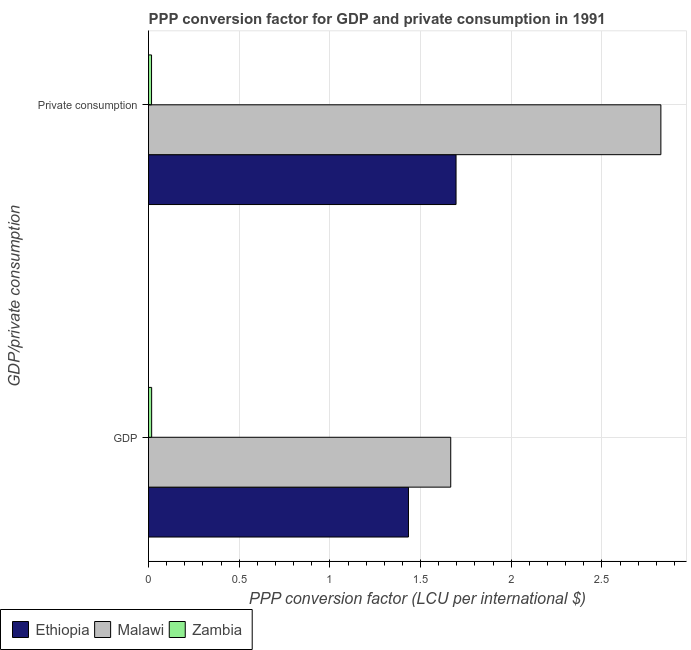How many different coloured bars are there?
Make the answer very short. 3. How many groups of bars are there?
Provide a succinct answer. 2. Are the number of bars per tick equal to the number of legend labels?
Offer a very short reply. Yes. Are the number of bars on each tick of the Y-axis equal?
Your answer should be compact. Yes. What is the label of the 1st group of bars from the top?
Your response must be concise.  Private consumption. What is the ppp conversion factor for private consumption in Malawi?
Your answer should be compact. 2.83. Across all countries, what is the maximum ppp conversion factor for private consumption?
Ensure brevity in your answer.  2.83. Across all countries, what is the minimum ppp conversion factor for private consumption?
Your answer should be compact. 0.02. In which country was the ppp conversion factor for private consumption maximum?
Your response must be concise. Malawi. In which country was the ppp conversion factor for gdp minimum?
Provide a succinct answer. Zambia. What is the total ppp conversion factor for gdp in the graph?
Make the answer very short. 3.12. What is the difference between the ppp conversion factor for gdp in Malawi and that in Zambia?
Your response must be concise. 1.65. What is the difference between the ppp conversion factor for gdp in Malawi and the ppp conversion factor for private consumption in Ethiopia?
Give a very brief answer. -0.03. What is the average ppp conversion factor for gdp per country?
Your response must be concise. 1.04. What is the difference between the ppp conversion factor for gdp and ppp conversion factor for private consumption in Zambia?
Keep it short and to the point. 0. In how many countries, is the ppp conversion factor for gdp greater than 2.2 LCU?
Provide a short and direct response. 0. What is the ratio of the ppp conversion factor for gdp in Malawi to that in Ethiopia?
Make the answer very short. 1.16. What does the 3rd bar from the top in GDP represents?
Ensure brevity in your answer.  Ethiopia. What does the 1st bar from the bottom in  Private consumption represents?
Offer a very short reply. Ethiopia. How many bars are there?
Your response must be concise. 6. Are all the bars in the graph horizontal?
Your answer should be compact. Yes. What is the difference between two consecutive major ticks on the X-axis?
Offer a very short reply. 0.5. Where does the legend appear in the graph?
Give a very brief answer. Bottom left. What is the title of the graph?
Your answer should be very brief. PPP conversion factor for GDP and private consumption in 1991. Does "Euro area" appear as one of the legend labels in the graph?
Offer a terse response. No. What is the label or title of the X-axis?
Make the answer very short. PPP conversion factor (LCU per international $). What is the label or title of the Y-axis?
Provide a short and direct response. GDP/private consumption. What is the PPP conversion factor (LCU per international $) in Ethiopia in GDP?
Provide a succinct answer. 1.43. What is the PPP conversion factor (LCU per international $) of Malawi in GDP?
Ensure brevity in your answer.  1.67. What is the PPP conversion factor (LCU per international $) of Zambia in GDP?
Your response must be concise. 0.02. What is the PPP conversion factor (LCU per international $) of Ethiopia in  Private consumption?
Offer a very short reply. 1.7. What is the PPP conversion factor (LCU per international $) in Malawi in  Private consumption?
Keep it short and to the point. 2.83. What is the PPP conversion factor (LCU per international $) of Zambia in  Private consumption?
Offer a very short reply. 0.02. Across all GDP/private consumption, what is the maximum PPP conversion factor (LCU per international $) of Ethiopia?
Your response must be concise. 1.7. Across all GDP/private consumption, what is the maximum PPP conversion factor (LCU per international $) of Malawi?
Your answer should be compact. 2.83. Across all GDP/private consumption, what is the maximum PPP conversion factor (LCU per international $) of Zambia?
Offer a terse response. 0.02. Across all GDP/private consumption, what is the minimum PPP conversion factor (LCU per international $) in Ethiopia?
Make the answer very short. 1.43. Across all GDP/private consumption, what is the minimum PPP conversion factor (LCU per international $) in Malawi?
Ensure brevity in your answer.  1.67. Across all GDP/private consumption, what is the minimum PPP conversion factor (LCU per international $) of Zambia?
Keep it short and to the point. 0.02. What is the total PPP conversion factor (LCU per international $) in Ethiopia in the graph?
Keep it short and to the point. 3.13. What is the total PPP conversion factor (LCU per international $) in Malawi in the graph?
Keep it short and to the point. 4.49. What is the total PPP conversion factor (LCU per international $) of Zambia in the graph?
Offer a very short reply. 0.03. What is the difference between the PPP conversion factor (LCU per international $) in Ethiopia in GDP and that in  Private consumption?
Keep it short and to the point. -0.26. What is the difference between the PPP conversion factor (LCU per international $) of Malawi in GDP and that in  Private consumption?
Ensure brevity in your answer.  -1.16. What is the difference between the PPP conversion factor (LCU per international $) in Zambia in GDP and that in  Private consumption?
Make the answer very short. 0. What is the difference between the PPP conversion factor (LCU per international $) of Ethiopia in GDP and the PPP conversion factor (LCU per international $) of Malawi in  Private consumption?
Keep it short and to the point. -1.39. What is the difference between the PPP conversion factor (LCU per international $) in Ethiopia in GDP and the PPP conversion factor (LCU per international $) in Zambia in  Private consumption?
Make the answer very short. 1.42. What is the difference between the PPP conversion factor (LCU per international $) of Malawi in GDP and the PPP conversion factor (LCU per international $) of Zambia in  Private consumption?
Your answer should be very brief. 1.65. What is the average PPP conversion factor (LCU per international $) of Ethiopia per GDP/private consumption?
Keep it short and to the point. 1.56. What is the average PPP conversion factor (LCU per international $) in Malawi per GDP/private consumption?
Your response must be concise. 2.25. What is the average PPP conversion factor (LCU per international $) of Zambia per GDP/private consumption?
Your response must be concise. 0.02. What is the difference between the PPP conversion factor (LCU per international $) of Ethiopia and PPP conversion factor (LCU per international $) of Malawi in GDP?
Provide a succinct answer. -0.23. What is the difference between the PPP conversion factor (LCU per international $) of Ethiopia and PPP conversion factor (LCU per international $) of Zambia in GDP?
Offer a very short reply. 1.42. What is the difference between the PPP conversion factor (LCU per international $) of Malawi and PPP conversion factor (LCU per international $) of Zambia in GDP?
Your response must be concise. 1.65. What is the difference between the PPP conversion factor (LCU per international $) of Ethiopia and PPP conversion factor (LCU per international $) of Malawi in  Private consumption?
Your answer should be compact. -1.13. What is the difference between the PPP conversion factor (LCU per international $) in Ethiopia and PPP conversion factor (LCU per international $) in Zambia in  Private consumption?
Make the answer very short. 1.68. What is the difference between the PPP conversion factor (LCU per international $) of Malawi and PPP conversion factor (LCU per international $) of Zambia in  Private consumption?
Make the answer very short. 2.81. What is the ratio of the PPP conversion factor (LCU per international $) of Ethiopia in GDP to that in  Private consumption?
Give a very brief answer. 0.85. What is the ratio of the PPP conversion factor (LCU per international $) in Malawi in GDP to that in  Private consumption?
Ensure brevity in your answer.  0.59. What is the ratio of the PPP conversion factor (LCU per international $) in Zambia in GDP to that in  Private consumption?
Give a very brief answer. 1.04. What is the difference between the highest and the second highest PPP conversion factor (LCU per international $) of Ethiopia?
Offer a very short reply. 0.26. What is the difference between the highest and the second highest PPP conversion factor (LCU per international $) in Malawi?
Provide a succinct answer. 1.16. What is the difference between the highest and the second highest PPP conversion factor (LCU per international $) in Zambia?
Provide a succinct answer. 0. What is the difference between the highest and the lowest PPP conversion factor (LCU per international $) of Ethiopia?
Give a very brief answer. 0.26. What is the difference between the highest and the lowest PPP conversion factor (LCU per international $) in Malawi?
Ensure brevity in your answer.  1.16. What is the difference between the highest and the lowest PPP conversion factor (LCU per international $) in Zambia?
Provide a succinct answer. 0. 